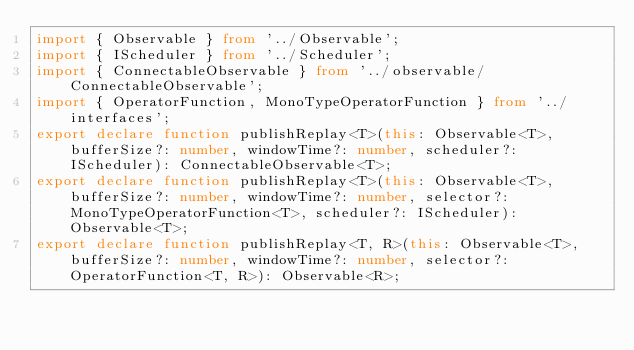<code> <loc_0><loc_0><loc_500><loc_500><_TypeScript_>import { Observable } from '../Observable';
import { IScheduler } from '../Scheduler';
import { ConnectableObservable } from '../observable/ConnectableObservable';
import { OperatorFunction, MonoTypeOperatorFunction } from '../interfaces';
export declare function publishReplay<T>(this: Observable<T>, bufferSize?: number, windowTime?: number, scheduler?: IScheduler): ConnectableObservable<T>;
export declare function publishReplay<T>(this: Observable<T>, bufferSize?: number, windowTime?: number, selector?: MonoTypeOperatorFunction<T>, scheduler?: IScheduler): Observable<T>;
export declare function publishReplay<T, R>(this: Observable<T>, bufferSize?: number, windowTime?: number, selector?: OperatorFunction<T, R>): Observable<R>;
</code> 